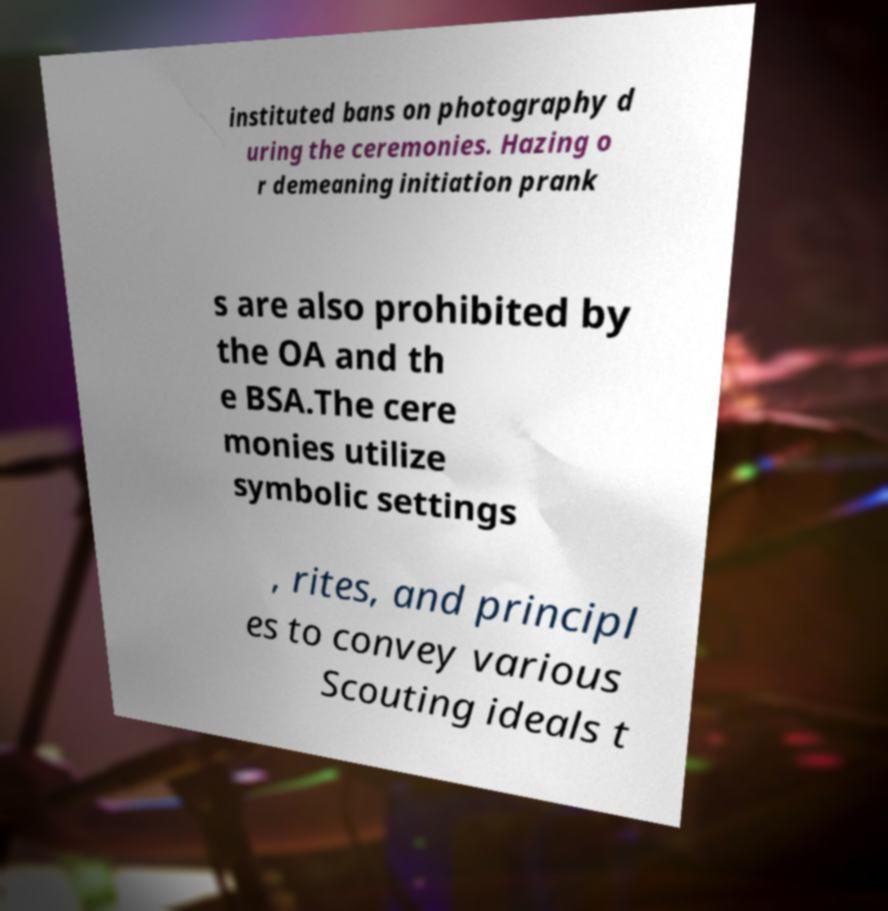Could you extract and type out the text from this image? instituted bans on photography d uring the ceremonies. Hazing o r demeaning initiation prank s are also prohibited by the OA and th e BSA.The cere monies utilize symbolic settings , rites, and principl es to convey various Scouting ideals t 